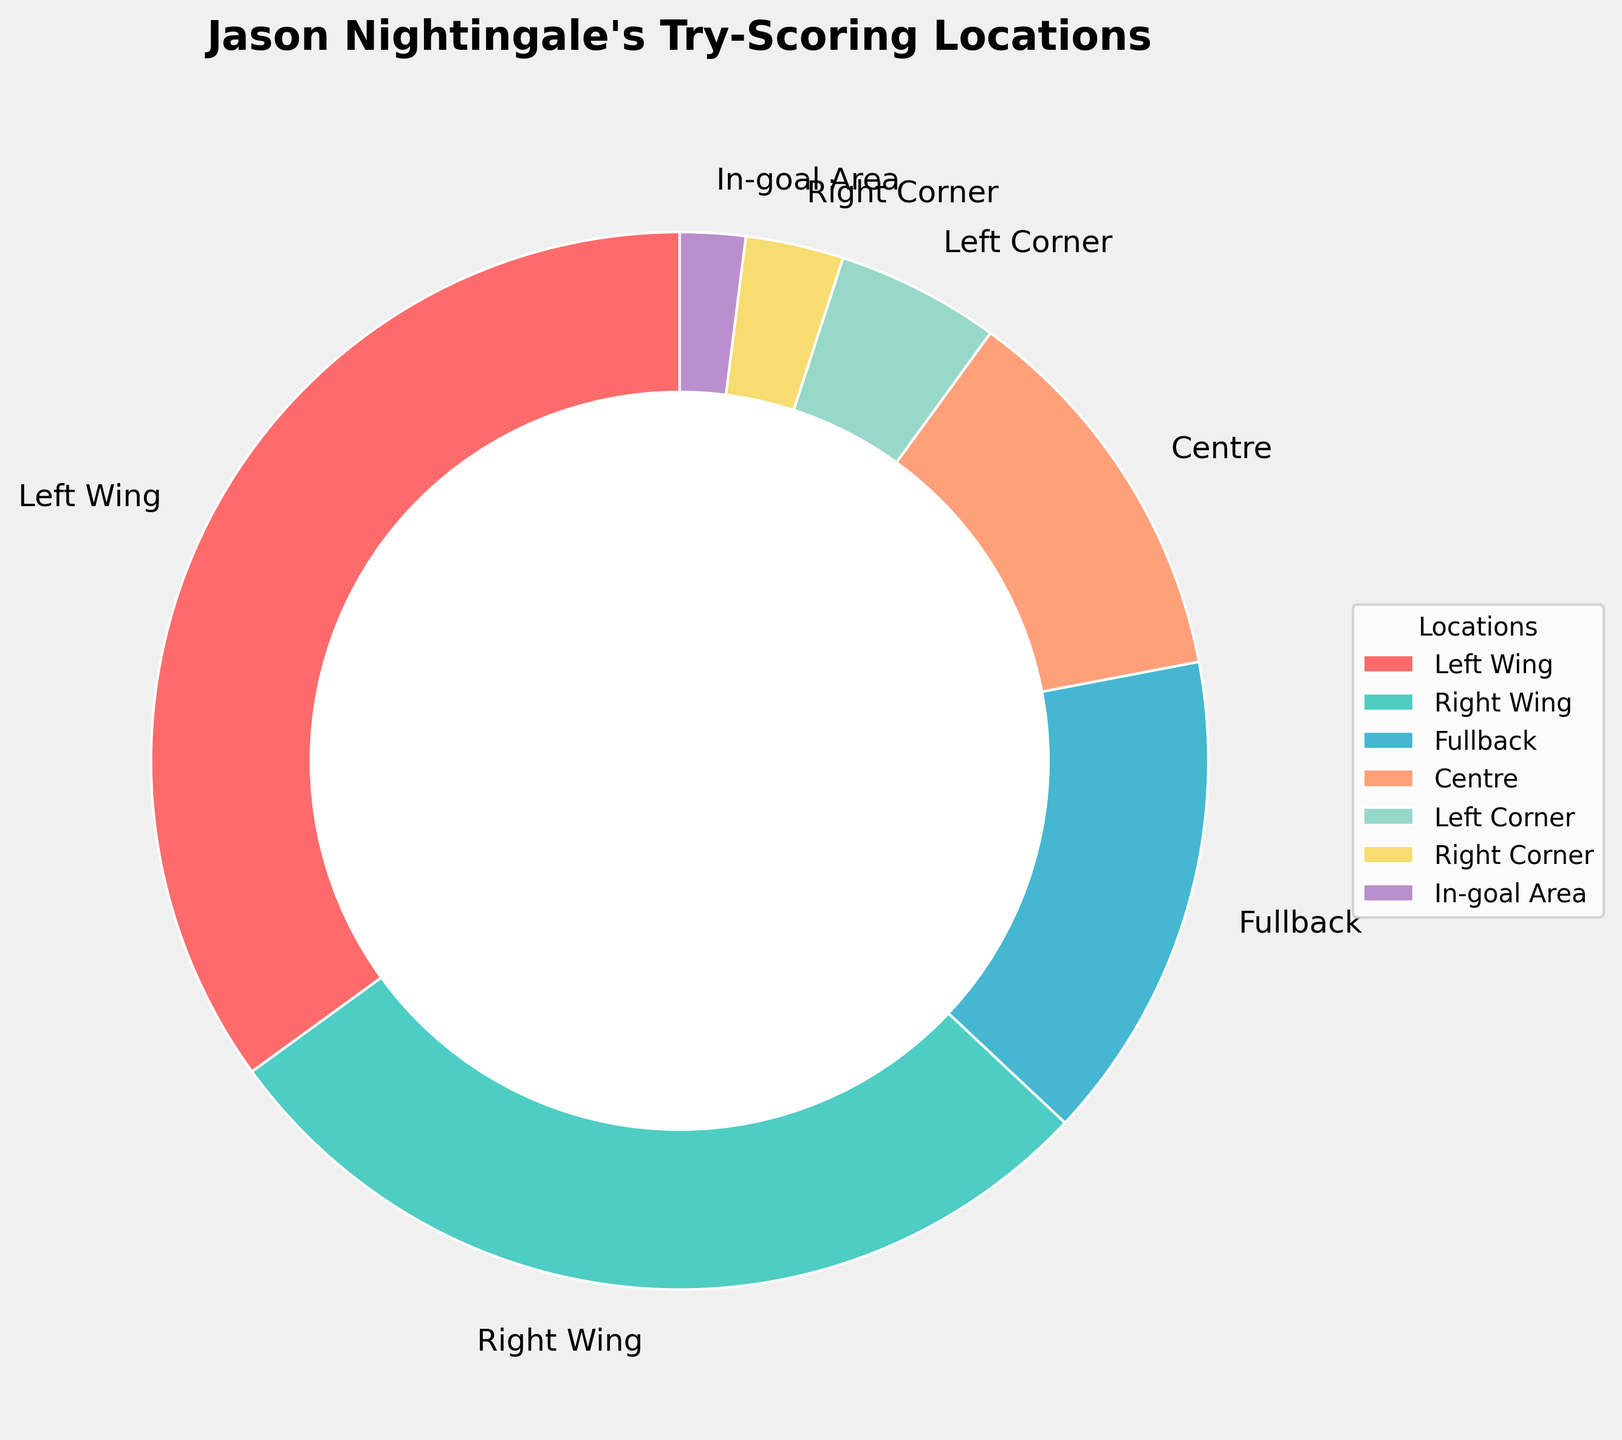Which location has the highest percentage of Jason Nightingale's career try-scoring locations? The pie chart shows that the location with the highest percentage of tries is the "Left Wing" as it occupies the largest segment of the chart.
Answer: Left Wing Which two locations combined make up more than half of the try-scoring locations? Left Wing with 35% and Right Wing with 28% make up more than half of the pie, summing to 35% + 28% = 63%.
Answer: Left Wing and Right Wing How much more does the Left Wing contribute compared to the Fullback in terms of percentage? The Left Wing contributes 35% and the Fullback contributes 15%. The difference is 35% - 15% = 20%.
Answer: 20% What is the combined percentage of tries scored in the Centre and the Left Corner? The Centre is 12% and the Left Corner is 5%. The combined percentage is 12% + 5% = 17%.
Answer: 17% Which location has the smallest percentage of tries scored? The segment labeled "In-goal Area" is the smallest, indicating it has the lowest percentage of tries scored at 2%.
Answer: In-goal Area How does the percentage of tries scored as a Fullback compare to tries scored on the Right Wing? The Fullback has 15% of the tries, and the Right Wing has 28%. To compare, we observe that 28% > 15%.
Answer: Less than Are there more tries scored on the Left Corner or the Right Corner? The Left Corner has a larger segment at 5% compared to the Right Corner at 3%. Therefore, more tries are scored on the Left Corner.
Answer: Left Corner What is the total percentage of tries scored on the corners combined (Left Corner and Right Corner)? The Left Corner contributes 5% and the Right Corner contributes 3%. The combined percentage is 5% + 3% = 8%.
Answer: 8% Which pair of locations together accounts for 43% of the try-scoring locations? By reviewing all pairs, we find that Fullback (15%) and Right Wing (28%) together make 43% (15% + 28% = 43%).
Answer: Fullback and Right Wing If you combine the percentage of tries in the Centre and Right Corner, is it more than tries scored as a Fullback? Centre's 12% combined with Right Corner's 3% results in 12% + 3% = 15%, which is equal to the percentage of tries scored as a Fullback.
Answer: Equal to 